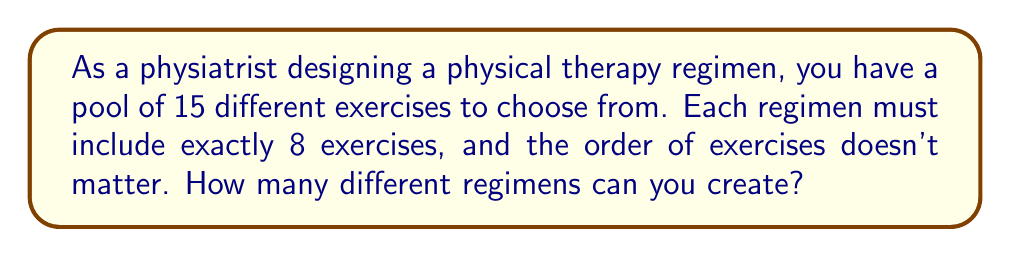Can you solve this math problem? To solve this problem, we need to use the combination formula. Here's the step-by-step approach:

1) This is a combination problem because:
   - We are selecting exercises from a larger pool
   - The order doesn't matter (e.g., Exercise A followed by B is the same as B followed by A)
   - We are selecting a specific number of exercises (8) from a larger set (15)

2) The combination formula is:

   $${n \choose k} = \frac{n!}{k!(n-k)!}$$

   Where $n$ is the total number of items to choose from, and $k$ is the number of items being chosen.

3) In this case:
   $n = 15$ (total exercises)
   $k = 8$ (exercises in each regimen)

4) Let's substitute these values into the formula:

   $${15 \choose 8} = \frac{15!}{8!(15-8)!} = \frac{15!}{8!(7)!}$$

5) Expand this:
   $$\frac{15 \times 14 \times 13 \times 12 \times 11 \times 10 \times 9 \times 8 \times 7!}{(8 \times 7 \times 6 \times 5 \times 4 \times 3 \times 2 \times 1) \times 7!}$$

6) The 7! cancels out in the numerator and denominator:

   $$\frac{15 \times 14 \times 13 \times 12 \times 11 \times 10 \times 9 \times 8}{8 \times 7 \times 6 \times 5 \times 4 \times 3 \times 2 \times 1}$$

7) Calculate:
   $$\frac{24,024,024}{40,320} = 6,435$$

Therefore, you can create 6,435 different physical therapy regimens.
Answer: 6,435 